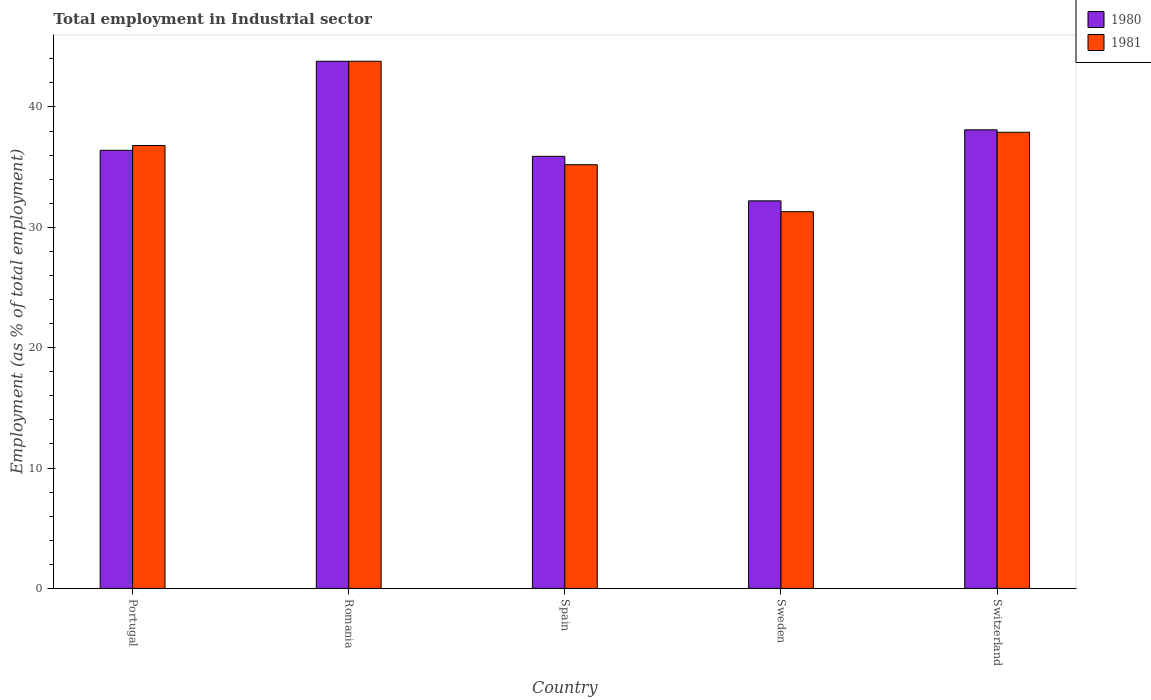How many different coloured bars are there?
Your answer should be very brief. 2. How many groups of bars are there?
Your answer should be very brief. 5. Are the number of bars on each tick of the X-axis equal?
Make the answer very short. Yes. How many bars are there on the 3rd tick from the left?
Ensure brevity in your answer.  2. What is the label of the 1st group of bars from the left?
Make the answer very short. Portugal. In how many cases, is the number of bars for a given country not equal to the number of legend labels?
Give a very brief answer. 0. What is the employment in industrial sector in 1981 in Sweden?
Provide a succinct answer. 31.3. Across all countries, what is the maximum employment in industrial sector in 1980?
Ensure brevity in your answer.  43.8. Across all countries, what is the minimum employment in industrial sector in 1981?
Offer a terse response. 31.3. In which country was the employment in industrial sector in 1980 maximum?
Offer a terse response. Romania. What is the total employment in industrial sector in 1981 in the graph?
Your answer should be very brief. 185. What is the difference between the employment in industrial sector in 1980 in Portugal and that in Romania?
Your answer should be compact. -7.4. What is the average employment in industrial sector in 1980 per country?
Offer a very short reply. 37.28. In how many countries, is the employment in industrial sector in 1981 greater than 8 %?
Give a very brief answer. 5. What is the ratio of the employment in industrial sector in 1981 in Romania to that in Switzerland?
Ensure brevity in your answer.  1.16. Is the difference between the employment in industrial sector in 1981 in Portugal and Sweden greater than the difference between the employment in industrial sector in 1980 in Portugal and Sweden?
Offer a terse response. Yes. What is the difference between the highest and the second highest employment in industrial sector in 1981?
Offer a terse response. 7. What is the difference between the highest and the lowest employment in industrial sector in 1981?
Offer a very short reply. 12.5. Is the sum of the employment in industrial sector in 1981 in Romania and Switzerland greater than the maximum employment in industrial sector in 1980 across all countries?
Your response must be concise. Yes. What does the 1st bar from the left in Portugal represents?
Give a very brief answer. 1980. Are all the bars in the graph horizontal?
Keep it short and to the point. No. Are the values on the major ticks of Y-axis written in scientific E-notation?
Offer a very short reply. No. Does the graph contain any zero values?
Keep it short and to the point. No. What is the title of the graph?
Offer a very short reply. Total employment in Industrial sector. Does "1962" appear as one of the legend labels in the graph?
Keep it short and to the point. No. What is the label or title of the Y-axis?
Your answer should be compact. Employment (as % of total employment). What is the Employment (as % of total employment) of 1980 in Portugal?
Your response must be concise. 36.4. What is the Employment (as % of total employment) in 1981 in Portugal?
Ensure brevity in your answer.  36.8. What is the Employment (as % of total employment) of 1980 in Romania?
Offer a very short reply. 43.8. What is the Employment (as % of total employment) of 1981 in Romania?
Your answer should be very brief. 43.8. What is the Employment (as % of total employment) in 1980 in Spain?
Your answer should be compact. 35.9. What is the Employment (as % of total employment) of 1981 in Spain?
Offer a very short reply. 35.2. What is the Employment (as % of total employment) of 1980 in Sweden?
Give a very brief answer. 32.2. What is the Employment (as % of total employment) in 1981 in Sweden?
Give a very brief answer. 31.3. What is the Employment (as % of total employment) in 1980 in Switzerland?
Ensure brevity in your answer.  38.1. What is the Employment (as % of total employment) in 1981 in Switzerland?
Give a very brief answer. 37.9. Across all countries, what is the maximum Employment (as % of total employment) of 1980?
Provide a succinct answer. 43.8. Across all countries, what is the maximum Employment (as % of total employment) of 1981?
Provide a succinct answer. 43.8. Across all countries, what is the minimum Employment (as % of total employment) in 1980?
Give a very brief answer. 32.2. Across all countries, what is the minimum Employment (as % of total employment) of 1981?
Your response must be concise. 31.3. What is the total Employment (as % of total employment) of 1980 in the graph?
Offer a terse response. 186.4. What is the total Employment (as % of total employment) of 1981 in the graph?
Your answer should be compact. 185. What is the difference between the Employment (as % of total employment) of 1980 in Portugal and that in Romania?
Your answer should be compact. -7.4. What is the difference between the Employment (as % of total employment) of 1981 in Portugal and that in Spain?
Offer a terse response. 1.6. What is the difference between the Employment (as % of total employment) of 1981 in Portugal and that in Switzerland?
Ensure brevity in your answer.  -1.1. What is the difference between the Employment (as % of total employment) in 1980 in Romania and that in Spain?
Make the answer very short. 7.9. What is the difference between the Employment (as % of total employment) of 1981 in Romania and that in Spain?
Make the answer very short. 8.6. What is the difference between the Employment (as % of total employment) in 1981 in Romania and that in Sweden?
Provide a succinct answer. 12.5. What is the difference between the Employment (as % of total employment) of 1980 in Romania and that in Switzerland?
Offer a terse response. 5.7. What is the difference between the Employment (as % of total employment) of 1981 in Romania and that in Switzerland?
Make the answer very short. 5.9. What is the difference between the Employment (as % of total employment) of 1981 in Spain and that in Sweden?
Offer a very short reply. 3.9. What is the difference between the Employment (as % of total employment) in 1980 in Spain and that in Switzerland?
Give a very brief answer. -2.2. What is the difference between the Employment (as % of total employment) of 1981 in Spain and that in Switzerland?
Offer a terse response. -2.7. What is the difference between the Employment (as % of total employment) in 1980 in Portugal and the Employment (as % of total employment) in 1981 in Romania?
Ensure brevity in your answer.  -7.4. What is the difference between the Employment (as % of total employment) in 1980 in Portugal and the Employment (as % of total employment) in 1981 in Sweden?
Your response must be concise. 5.1. What is the difference between the Employment (as % of total employment) in 1980 in Romania and the Employment (as % of total employment) in 1981 in Sweden?
Keep it short and to the point. 12.5. What is the difference between the Employment (as % of total employment) of 1980 in Romania and the Employment (as % of total employment) of 1981 in Switzerland?
Give a very brief answer. 5.9. What is the difference between the Employment (as % of total employment) in 1980 in Spain and the Employment (as % of total employment) in 1981 in Sweden?
Ensure brevity in your answer.  4.6. What is the difference between the Employment (as % of total employment) of 1980 in Sweden and the Employment (as % of total employment) of 1981 in Switzerland?
Your response must be concise. -5.7. What is the average Employment (as % of total employment) of 1980 per country?
Your answer should be very brief. 37.28. What is the difference between the Employment (as % of total employment) of 1980 and Employment (as % of total employment) of 1981 in Romania?
Your answer should be compact. 0. What is the difference between the Employment (as % of total employment) in 1980 and Employment (as % of total employment) in 1981 in Spain?
Make the answer very short. 0.7. What is the difference between the Employment (as % of total employment) of 1980 and Employment (as % of total employment) of 1981 in Sweden?
Offer a terse response. 0.9. What is the ratio of the Employment (as % of total employment) of 1980 in Portugal to that in Romania?
Offer a terse response. 0.83. What is the ratio of the Employment (as % of total employment) in 1981 in Portugal to that in Romania?
Your answer should be compact. 0.84. What is the ratio of the Employment (as % of total employment) of 1980 in Portugal to that in Spain?
Provide a succinct answer. 1.01. What is the ratio of the Employment (as % of total employment) of 1981 in Portugal to that in Spain?
Provide a succinct answer. 1.05. What is the ratio of the Employment (as % of total employment) of 1980 in Portugal to that in Sweden?
Your response must be concise. 1.13. What is the ratio of the Employment (as % of total employment) of 1981 in Portugal to that in Sweden?
Provide a succinct answer. 1.18. What is the ratio of the Employment (as % of total employment) in 1980 in Portugal to that in Switzerland?
Offer a very short reply. 0.96. What is the ratio of the Employment (as % of total employment) in 1980 in Romania to that in Spain?
Offer a very short reply. 1.22. What is the ratio of the Employment (as % of total employment) in 1981 in Romania to that in Spain?
Provide a short and direct response. 1.24. What is the ratio of the Employment (as % of total employment) of 1980 in Romania to that in Sweden?
Your answer should be compact. 1.36. What is the ratio of the Employment (as % of total employment) of 1981 in Romania to that in Sweden?
Ensure brevity in your answer.  1.4. What is the ratio of the Employment (as % of total employment) in 1980 in Romania to that in Switzerland?
Make the answer very short. 1.15. What is the ratio of the Employment (as % of total employment) of 1981 in Romania to that in Switzerland?
Provide a succinct answer. 1.16. What is the ratio of the Employment (as % of total employment) in 1980 in Spain to that in Sweden?
Your answer should be very brief. 1.11. What is the ratio of the Employment (as % of total employment) of 1981 in Spain to that in Sweden?
Your response must be concise. 1.12. What is the ratio of the Employment (as % of total employment) of 1980 in Spain to that in Switzerland?
Provide a short and direct response. 0.94. What is the ratio of the Employment (as % of total employment) in 1981 in Spain to that in Switzerland?
Provide a short and direct response. 0.93. What is the ratio of the Employment (as % of total employment) in 1980 in Sweden to that in Switzerland?
Make the answer very short. 0.85. What is the ratio of the Employment (as % of total employment) in 1981 in Sweden to that in Switzerland?
Ensure brevity in your answer.  0.83. What is the difference between the highest and the second highest Employment (as % of total employment) of 1980?
Give a very brief answer. 5.7. What is the difference between the highest and the lowest Employment (as % of total employment) in 1980?
Offer a terse response. 11.6. What is the difference between the highest and the lowest Employment (as % of total employment) in 1981?
Keep it short and to the point. 12.5. 